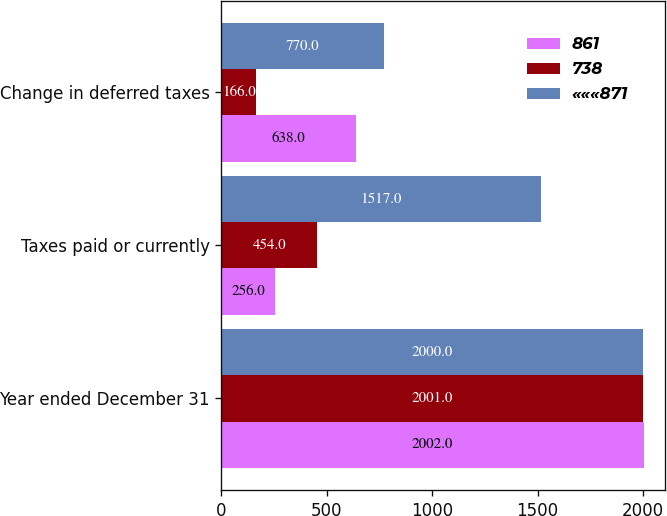Convert chart to OTSL. <chart><loc_0><loc_0><loc_500><loc_500><stacked_bar_chart><ecel><fcel>Year ended December 31<fcel>Taxes paid or currently<fcel>Change in deferred taxes<nl><fcel>861<fcel>2002<fcel>256<fcel>638<nl><fcel>738<fcel>2001<fcel>454<fcel>166<nl><fcel>«««871<fcel>2000<fcel>1517<fcel>770<nl></chart> 